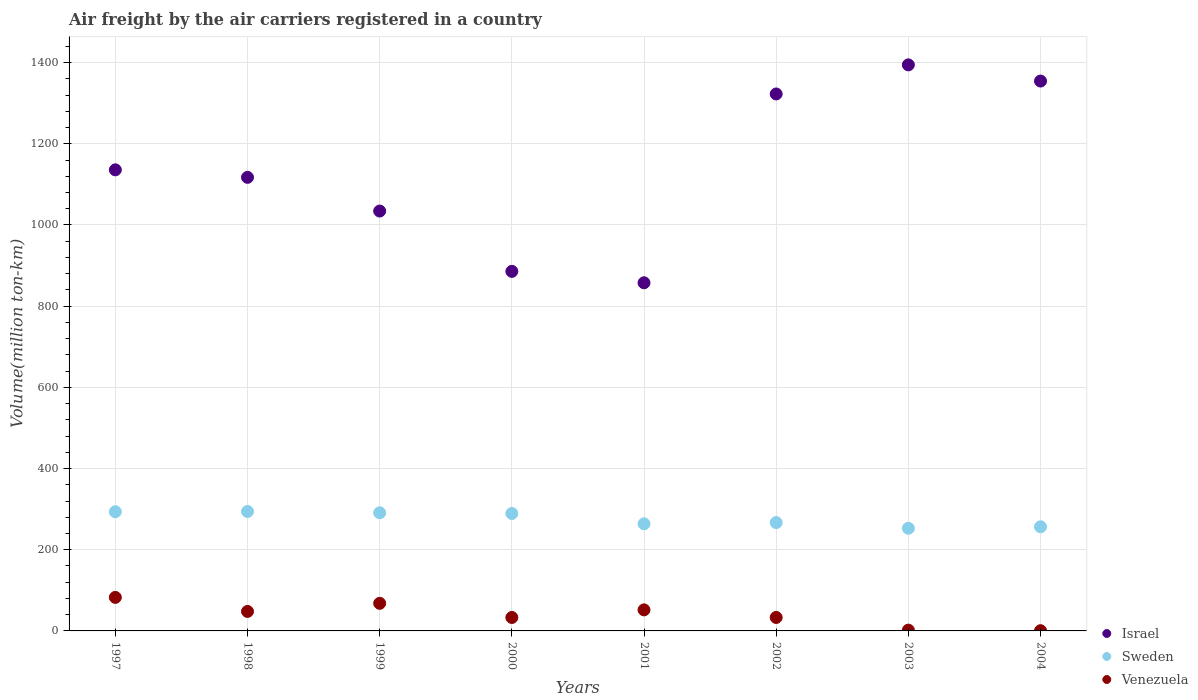How many different coloured dotlines are there?
Offer a terse response. 3. Is the number of dotlines equal to the number of legend labels?
Provide a short and direct response. Yes. What is the volume of the air carriers in Venezuela in 2002?
Provide a short and direct response. 33.17. Across all years, what is the maximum volume of the air carriers in Sweden?
Your response must be concise. 294.2. Across all years, what is the minimum volume of the air carriers in Sweden?
Make the answer very short. 252.88. What is the total volume of the air carriers in Israel in the graph?
Keep it short and to the point. 9102.32. What is the difference between the volume of the air carriers in Israel in 1997 and that in 1998?
Your answer should be very brief. 18.5. What is the difference between the volume of the air carriers in Sweden in 1999 and the volume of the air carriers in Venezuela in 2000?
Offer a very short reply. 257.9. What is the average volume of the air carriers in Israel per year?
Your response must be concise. 1137.79. In the year 2002, what is the difference between the volume of the air carriers in Sweden and volume of the air carriers in Israel?
Offer a terse response. -1055.88. In how many years, is the volume of the air carriers in Israel greater than 1040 million ton-km?
Your answer should be very brief. 5. What is the ratio of the volume of the air carriers in Venezuela in 2000 to that in 2001?
Keep it short and to the point. 0.64. Is the difference between the volume of the air carriers in Sweden in 2001 and 2002 greater than the difference between the volume of the air carriers in Israel in 2001 and 2002?
Keep it short and to the point. Yes. What is the difference between the highest and the second highest volume of the air carriers in Sweden?
Your answer should be compact. 0.6. What is the difference between the highest and the lowest volume of the air carriers in Sweden?
Give a very brief answer. 41.32. Is it the case that in every year, the sum of the volume of the air carriers in Venezuela and volume of the air carriers in Sweden  is greater than the volume of the air carriers in Israel?
Offer a very short reply. No. Does the volume of the air carriers in Israel monotonically increase over the years?
Your answer should be compact. No. Is the volume of the air carriers in Sweden strictly less than the volume of the air carriers in Venezuela over the years?
Give a very brief answer. No. How many dotlines are there?
Your answer should be compact. 3. How many years are there in the graph?
Ensure brevity in your answer.  8. What is the difference between two consecutive major ticks on the Y-axis?
Offer a very short reply. 200. Does the graph contain any zero values?
Your answer should be compact. No. Does the graph contain grids?
Give a very brief answer. Yes. Where does the legend appear in the graph?
Your answer should be compact. Bottom right. What is the title of the graph?
Ensure brevity in your answer.  Air freight by the air carriers registered in a country. Does "Malta" appear as one of the legend labels in the graph?
Offer a terse response. No. What is the label or title of the Y-axis?
Give a very brief answer. Volume(million ton-km). What is the Volume(million ton-km) of Israel in 1997?
Provide a succinct answer. 1135.8. What is the Volume(million ton-km) of Sweden in 1997?
Offer a terse response. 293.6. What is the Volume(million ton-km) in Venezuela in 1997?
Offer a very short reply. 82.6. What is the Volume(million ton-km) in Israel in 1998?
Your answer should be very brief. 1117.3. What is the Volume(million ton-km) of Sweden in 1998?
Make the answer very short. 294.2. What is the Volume(million ton-km) in Israel in 1999?
Give a very brief answer. 1034.3. What is the Volume(million ton-km) in Sweden in 1999?
Make the answer very short. 291. What is the Volume(million ton-km) of Venezuela in 1999?
Your response must be concise. 68. What is the Volume(million ton-km) in Israel in 2000?
Your answer should be compact. 885.7. What is the Volume(million ton-km) of Sweden in 2000?
Your answer should be very brief. 289.29. What is the Volume(million ton-km) in Venezuela in 2000?
Keep it short and to the point. 33.1. What is the Volume(million ton-km) of Israel in 2001?
Give a very brief answer. 857.56. What is the Volume(million ton-km) in Sweden in 2001?
Your response must be concise. 263.79. What is the Volume(million ton-km) of Venezuela in 2001?
Give a very brief answer. 51.86. What is the Volume(million ton-km) of Israel in 2002?
Provide a succinct answer. 1322.72. What is the Volume(million ton-km) of Sweden in 2002?
Offer a terse response. 266.84. What is the Volume(million ton-km) of Venezuela in 2002?
Provide a short and direct response. 33.17. What is the Volume(million ton-km) of Israel in 2003?
Ensure brevity in your answer.  1394.4. What is the Volume(million ton-km) in Sweden in 2003?
Give a very brief answer. 252.88. What is the Volume(million ton-km) of Venezuela in 2003?
Offer a terse response. 1.94. What is the Volume(million ton-km) in Israel in 2004?
Provide a short and direct response. 1354.54. What is the Volume(million ton-km) of Sweden in 2004?
Provide a short and direct response. 256.52. What is the Volume(million ton-km) of Venezuela in 2004?
Give a very brief answer. 0.56. Across all years, what is the maximum Volume(million ton-km) in Israel?
Your response must be concise. 1394.4. Across all years, what is the maximum Volume(million ton-km) in Sweden?
Your answer should be very brief. 294.2. Across all years, what is the maximum Volume(million ton-km) of Venezuela?
Provide a short and direct response. 82.6. Across all years, what is the minimum Volume(million ton-km) of Israel?
Provide a short and direct response. 857.56. Across all years, what is the minimum Volume(million ton-km) in Sweden?
Ensure brevity in your answer.  252.88. Across all years, what is the minimum Volume(million ton-km) in Venezuela?
Provide a short and direct response. 0.56. What is the total Volume(million ton-km) in Israel in the graph?
Your answer should be compact. 9102.32. What is the total Volume(million ton-km) of Sweden in the graph?
Make the answer very short. 2208.11. What is the total Volume(million ton-km) of Venezuela in the graph?
Provide a succinct answer. 319.23. What is the difference between the Volume(million ton-km) of Israel in 1997 and that in 1998?
Keep it short and to the point. 18.5. What is the difference between the Volume(million ton-km) of Venezuela in 1997 and that in 1998?
Your response must be concise. 34.6. What is the difference between the Volume(million ton-km) of Israel in 1997 and that in 1999?
Keep it short and to the point. 101.5. What is the difference between the Volume(million ton-km) of Sweden in 1997 and that in 1999?
Ensure brevity in your answer.  2.6. What is the difference between the Volume(million ton-km) in Venezuela in 1997 and that in 1999?
Provide a short and direct response. 14.6. What is the difference between the Volume(million ton-km) of Israel in 1997 and that in 2000?
Make the answer very short. 250.1. What is the difference between the Volume(million ton-km) of Sweden in 1997 and that in 2000?
Your response must be concise. 4.32. What is the difference between the Volume(million ton-km) of Venezuela in 1997 and that in 2000?
Keep it short and to the point. 49.5. What is the difference between the Volume(million ton-km) of Israel in 1997 and that in 2001?
Your answer should be very brief. 278.24. What is the difference between the Volume(million ton-km) in Sweden in 1997 and that in 2001?
Give a very brief answer. 29.81. What is the difference between the Volume(million ton-km) of Venezuela in 1997 and that in 2001?
Your answer should be compact. 30.74. What is the difference between the Volume(million ton-km) in Israel in 1997 and that in 2002?
Your response must be concise. -186.92. What is the difference between the Volume(million ton-km) in Sweden in 1997 and that in 2002?
Make the answer very short. 26.76. What is the difference between the Volume(million ton-km) of Venezuela in 1997 and that in 2002?
Provide a succinct answer. 49.43. What is the difference between the Volume(million ton-km) in Israel in 1997 and that in 2003?
Keep it short and to the point. -258.6. What is the difference between the Volume(million ton-km) in Sweden in 1997 and that in 2003?
Provide a short and direct response. 40.72. What is the difference between the Volume(million ton-km) of Venezuela in 1997 and that in 2003?
Offer a terse response. 80.66. What is the difference between the Volume(million ton-km) of Israel in 1997 and that in 2004?
Keep it short and to the point. -218.74. What is the difference between the Volume(million ton-km) in Sweden in 1997 and that in 2004?
Offer a terse response. 37.08. What is the difference between the Volume(million ton-km) of Venezuela in 1997 and that in 2004?
Your response must be concise. 82.04. What is the difference between the Volume(million ton-km) in Israel in 1998 and that in 1999?
Offer a very short reply. 83. What is the difference between the Volume(million ton-km) in Sweden in 1998 and that in 1999?
Make the answer very short. 3.2. What is the difference between the Volume(million ton-km) of Venezuela in 1998 and that in 1999?
Your answer should be very brief. -20. What is the difference between the Volume(million ton-km) of Israel in 1998 and that in 2000?
Your response must be concise. 231.6. What is the difference between the Volume(million ton-km) in Sweden in 1998 and that in 2000?
Keep it short and to the point. 4.92. What is the difference between the Volume(million ton-km) in Israel in 1998 and that in 2001?
Offer a terse response. 259.74. What is the difference between the Volume(million ton-km) in Sweden in 1998 and that in 2001?
Make the answer very short. 30.41. What is the difference between the Volume(million ton-km) of Venezuela in 1998 and that in 2001?
Your answer should be compact. -3.86. What is the difference between the Volume(million ton-km) of Israel in 1998 and that in 2002?
Provide a short and direct response. -205.42. What is the difference between the Volume(million ton-km) of Sweden in 1998 and that in 2002?
Keep it short and to the point. 27.36. What is the difference between the Volume(million ton-km) of Venezuela in 1998 and that in 2002?
Give a very brief answer. 14.83. What is the difference between the Volume(million ton-km) of Israel in 1998 and that in 2003?
Your response must be concise. -277.1. What is the difference between the Volume(million ton-km) in Sweden in 1998 and that in 2003?
Your answer should be compact. 41.32. What is the difference between the Volume(million ton-km) in Venezuela in 1998 and that in 2003?
Keep it short and to the point. 46.06. What is the difference between the Volume(million ton-km) in Israel in 1998 and that in 2004?
Give a very brief answer. -237.24. What is the difference between the Volume(million ton-km) of Sweden in 1998 and that in 2004?
Provide a short and direct response. 37.68. What is the difference between the Volume(million ton-km) in Venezuela in 1998 and that in 2004?
Offer a very short reply. 47.44. What is the difference between the Volume(million ton-km) in Israel in 1999 and that in 2000?
Offer a very short reply. 148.6. What is the difference between the Volume(million ton-km) in Sweden in 1999 and that in 2000?
Offer a very short reply. 1.72. What is the difference between the Volume(million ton-km) of Venezuela in 1999 and that in 2000?
Keep it short and to the point. 34.9. What is the difference between the Volume(million ton-km) in Israel in 1999 and that in 2001?
Your response must be concise. 176.74. What is the difference between the Volume(million ton-km) of Sweden in 1999 and that in 2001?
Ensure brevity in your answer.  27.21. What is the difference between the Volume(million ton-km) of Venezuela in 1999 and that in 2001?
Ensure brevity in your answer.  16.14. What is the difference between the Volume(million ton-km) of Israel in 1999 and that in 2002?
Provide a short and direct response. -288.42. What is the difference between the Volume(million ton-km) in Sweden in 1999 and that in 2002?
Your response must be concise. 24.16. What is the difference between the Volume(million ton-km) in Venezuela in 1999 and that in 2002?
Provide a succinct answer. 34.83. What is the difference between the Volume(million ton-km) of Israel in 1999 and that in 2003?
Make the answer very short. -360.1. What is the difference between the Volume(million ton-km) of Sweden in 1999 and that in 2003?
Your answer should be very brief. 38.12. What is the difference between the Volume(million ton-km) in Venezuela in 1999 and that in 2003?
Give a very brief answer. 66.06. What is the difference between the Volume(million ton-km) of Israel in 1999 and that in 2004?
Your response must be concise. -320.24. What is the difference between the Volume(million ton-km) of Sweden in 1999 and that in 2004?
Make the answer very short. 34.48. What is the difference between the Volume(million ton-km) in Venezuela in 1999 and that in 2004?
Offer a terse response. 67.44. What is the difference between the Volume(million ton-km) in Israel in 2000 and that in 2001?
Ensure brevity in your answer.  28.14. What is the difference between the Volume(million ton-km) in Sweden in 2000 and that in 2001?
Your answer should be compact. 25.5. What is the difference between the Volume(million ton-km) in Venezuela in 2000 and that in 2001?
Keep it short and to the point. -18.76. What is the difference between the Volume(million ton-km) of Israel in 2000 and that in 2002?
Your answer should be compact. -437.01. What is the difference between the Volume(million ton-km) of Sweden in 2000 and that in 2002?
Your answer should be very brief. 22.45. What is the difference between the Volume(million ton-km) in Venezuela in 2000 and that in 2002?
Provide a short and direct response. -0.07. What is the difference between the Volume(million ton-km) in Israel in 2000 and that in 2003?
Provide a succinct answer. -508.69. What is the difference between the Volume(million ton-km) of Sweden in 2000 and that in 2003?
Offer a terse response. 36.41. What is the difference between the Volume(million ton-km) in Venezuela in 2000 and that in 2003?
Provide a succinct answer. 31.16. What is the difference between the Volume(million ton-km) in Israel in 2000 and that in 2004?
Your answer should be very brief. -468.83. What is the difference between the Volume(million ton-km) of Sweden in 2000 and that in 2004?
Offer a terse response. 32.77. What is the difference between the Volume(million ton-km) in Venezuela in 2000 and that in 2004?
Make the answer very short. 32.54. What is the difference between the Volume(million ton-km) in Israel in 2001 and that in 2002?
Provide a short and direct response. -465.16. What is the difference between the Volume(million ton-km) of Sweden in 2001 and that in 2002?
Give a very brief answer. -3.05. What is the difference between the Volume(million ton-km) of Venezuela in 2001 and that in 2002?
Give a very brief answer. 18.69. What is the difference between the Volume(million ton-km) in Israel in 2001 and that in 2003?
Provide a succinct answer. -536.84. What is the difference between the Volume(million ton-km) of Sweden in 2001 and that in 2003?
Give a very brief answer. 10.91. What is the difference between the Volume(million ton-km) in Venezuela in 2001 and that in 2003?
Your answer should be very brief. 49.92. What is the difference between the Volume(million ton-km) in Israel in 2001 and that in 2004?
Ensure brevity in your answer.  -496.98. What is the difference between the Volume(million ton-km) in Sweden in 2001 and that in 2004?
Give a very brief answer. 7.27. What is the difference between the Volume(million ton-km) in Venezuela in 2001 and that in 2004?
Your response must be concise. 51.3. What is the difference between the Volume(million ton-km) of Israel in 2002 and that in 2003?
Keep it short and to the point. -71.68. What is the difference between the Volume(million ton-km) of Sweden in 2002 and that in 2003?
Offer a very short reply. 13.96. What is the difference between the Volume(million ton-km) in Venezuela in 2002 and that in 2003?
Provide a succinct answer. 31.23. What is the difference between the Volume(million ton-km) in Israel in 2002 and that in 2004?
Offer a very short reply. -31.82. What is the difference between the Volume(million ton-km) in Sweden in 2002 and that in 2004?
Provide a succinct answer. 10.32. What is the difference between the Volume(million ton-km) in Venezuela in 2002 and that in 2004?
Provide a short and direct response. 32.61. What is the difference between the Volume(million ton-km) of Israel in 2003 and that in 2004?
Provide a short and direct response. 39.86. What is the difference between the Volume(million ton-km) in Sweden in 2003 and that in 2004?
Your answer should be very brief. -3.64. What is the difference between the Volume(million ton-km) of Venezuela in 2003 and that in 2004?
Make the answer very short. 1.38. What is the difference between the Volume(million ton-km) of Israel in 1997 and the Volume(million ton-km) of Sweden in 1998?
Give a very brief answer. 841.6. What is the difference between the Volume(million ton-km) in Israel in 1997 and the Volume(million ton-km) in Venezuela in 1998?
Ensure brevity in your answer.  1087.8. What is the difference between the Volume(million ton-km) in Sweden in 1997 and the Volume(million ton-km) in Venezuela in 1998?
Provide a short and direct response. 245.6. What is the difference between the Volume(million ton-km) of Israel in 1997 and the Volume(million ton-km) of Sweden in 1999?
Give a very brief answer. 844.8. What is the difference between the Volume(million ton-km) in Israel in 1997 and the Volume(million ton-km) in Venezuela in 1999?
Offer a terse response. 1067.8. What is the difference between the Volume(million ton-km) in Sweden in 1997 and the Volume(million ton-km) in Venezuela in 1999?
Keep it short and to the point. 225.6. What is the difference between the Volume(million ton-km) in Israel in 1997 and the Volume(million ton-km) in Sweden in 2000?
Your response must be concise. 846.51. What is the difference between the Volume(million ton-km) of Israel in 1997 and the Volume(million ton-km) of Venezuela in 2000?
Provide a succinct answer. 1102.7. What is the difference between the Volume(million ton-km) of Sweden in 1997 and the Volume(million ton-km) of Venezuela in 2000?
Make the answer very short. 260.5. What is the difference between the Volume(million ton-km) in Israel in 1997 and the Volume(million ton-km) in Sweden in 2001?
Your response must be concise. 872.01. What is the difference between the Volume(million ton-km) of Israel in 1997 and the Volume(million ton-km) of Venezuela in 2001?
Keep it short and to the point. 1083.94. What is the difference between the Volume(million ton-km) of Sweden in 1997 and the Volume(million ton-km) of Venezuela in 2001?
Offer a very short reply. 241.74. What is the difference between the Volume(million ton-km) of Israel in 1997 and the Volume(million ton-km) of Sweden in 2002?
Offer a terse response. 868.96. What is the difference between the Volume(million ton-km) of Israel in 1997 and the Volume(million ton-km) of Venezuela in 2002?
Provide a short and direct response. 1102.63. What is the difference between the Volume(million ton-km) of Sweden in 1997 and the Volume(million ton-km) of Venezuela in 2002?
Offer a very short reply. 260.43. What is the difference between the Volume(million ton-km) of Israel in 1997 and the Volume(million ton-km) of Sweden in 2003?
Provide a succinct answer. 882.92. What is the difference between the Volume(million ton-km) in Israel in 1997 and the Volume(million ton-km) in Venezuela in 2003?
Offer a terse response. 1133.86. What is the difference between the Volume(million ton-km) of Sweden in 1997 and the Volume(million ton-km) of Venezuela in 2003?
Provide a short and direct response. 291.66. What is the difference between the Volume(million ton-km) in Israel in 1997 and the Volume(million ton-km) in Sweden in 2004?
Provide a short and direct response. 879.28. What is the difference between the Volume(million ton-km) of Israel in 1997 and the Volume(million ton-km) of Venezuela in 2004?
Give a very brief answer. 1135.24. What is the difference between the Volume(million ton-km) in Sweden in 1997 and the Volume(million ton-km) in Venezuela in 2004?
Provide a succinct answer. 293.04. What is the difference between the Volume(million ton-km) of Israel in 1998 and the Volume(million ton-km) of Sweden in 1999?
Keep it short and to the point. 826.3. What is the difference between the Volume(million ton-km) in Israel in 1998 and the Volume(million ton-km) in Venezuela in 1999?
Make the answer very short. 1049.3. What is the difference between the Volume(million ton-km) of Sweden in 1998 and the Volume(million ton-km) of Venezuela in 1999?
Give a very brief answer. 226.2. What is the difference between the Volume(million ton-km) in Israel in 1998 and the Volume(million ton-km) in Sweden in 2000?
Provide a succinct answer. 828.01. What is the difference between the Volume(million ton-km) in Israel in 1998 and the Volume(million ton-km) in Venezuela in 2000?
Your response must be concise. 1084.2. What is the difference between the Volume(million ton-km) of Sweden in 1998 and the Volume(million ton-km) of Venezuela in 2000?
Offer a very short reply. 261.1. What is the difference between the Volume(million ton-km) in Israel in 1998 and the Volume(million ton-km) in Sweden in 2001?
Offer a very short reply. 853.51. What is the difference between the Volume(million ton-km) in Israel in 1998 and the Volume(million ton-km) in Venezuela in 2001?
Offer a very short reply. 1065.44. What is the difference between the Volume(million ton-km) of Sweden in 1998 and the Volume(million ton-km) of Venezuela in 2001?
Your answer should be very brief. 242.34. What is the difference between the Volume(million ton-km) of Israel in 1998 and the Volume(million ton-km) of Sweden in 2002?
Your answer should be compact. 850.46. What is the difference between the Volume(million ton-km) of Israel in 1998 and the Volume(million ton-km) of Venezuela in 2002?
Offer a terse response. 1084.13. What is the difference between the Volume(million ton-km) in Sweden in 1998 and the Volume(million ton-km) in Venezuela in 2002?
Provide a short and direct response. 261.03. What is the difference between the Volume(million ton-km) in Israel in 1998 and the Volume(million ton-km) in Sweden in 2003?
Make the answer very short. 864.42. What is the difference between the Volume(million ton-km) in Israel in 1998 and the Volume(million ton-km) in Venezuela in 2003?
Offer a very short reply. 1115.36. What is the difference between the Volume(million ton-km) of Sweden in 1998 and the Volume(million ton-km) of Venezuela in 2003?
Give a very brief answer. 292.26. What is the difference between the Volume(million ton-km) in Israel in 1998 and the Volume(million ton-km) in Sweden in 2004?
Provide a short and direct response. 860.78. What is the difference between the Volume(million ton-km) in Israel in 1998 and the Volume(million ton-km) in Venezuela in 2004?
Keep it short and to the point. 1116.74. What is the difference between the Volume(million ton-km) in Sweden in 1998 and the Volume(million ton-km) in Venezuela in 2004?
Give a very brief answer. 293.64. What is the difference between the Volume(million ton-km) of Israel in 1999 and the Volume(million ton-km) of Sweden in 2000?
Offer a very short reply. 745.01. What is the difference between the Volume(million ton-km) in Israel in 1999 and the Volume(million ton-km) in Venezuela in 2000?
Provide a succinct answer. 1001.2. What is the difference between the Volume(million ton-km) of Sweden in 1999 and the Volume(million ton-km) of Venezuela in 2000?
Your answer should be very brief. 257.9. What is the difference between the Volume(million ton-km) of Israel in 1999 and the Volume(million ton-km) of Sweden in 2001?
Your answer should be compact. 770.51. What is the difference between the Volume(million ton-km) in Israel in 1999 and the Volume(million ton-km) in Venezuela in 2001?
Provide a short and direct response. 982.44. What is the difference between the Volume(million ton-km) of Sweden in 1999 and the Volume(million ton-km) of Venezuela in 2001?
Provide a short and direct response. 239.14. What is the difference between the Volume(million ton-km) of Israel in 1999 and the Volume(million ton-km) of Sweden in 2002?
Ensure brevity in your answer.  767.46. What is the difference between the Volume(million ton-km) in Israel in 1999 and the Volume(million ton-km) in Venezuela in 2002?
Your answer should be compact. 1001.13. What is the difference between the Volume(million ton-km) in Sweden in 1999 and the Volume(million ton-km) in Venezuela in 2002?
Ensure brevity in your answer.  257.83. What is the difference between the Volume(million ton-km) in Israel in 1999 and the Volume(million ton-km) in Sweden in 2003?
Offer a very short reply. 781.42. What is the difference between the Volume(million ton-km) of Israel in 1999 and the Volume(million ton-km) of Venezuela in 2003?
Provide a succinct answer. 1032.36. What is the difference between the Volume(million ton-km) in Sweden in 1999 and the Volume(million ton-km) in Venezuela in 2003?
Offer a very short reply. 289.06. What is the difference between the Volume(million ton-km) in Israel in 1999 and the Volume(million ton-km) in Sweden in 2004?
Provide a short and direct response. 777.78. What is the difference between the Volume(million ton-km) in Israel in 1999 and the Volume(million ton-km) in Venezuela in 2004?
Ensure brevity in your answer.  1033.74. What is the difference between the Volume(million ton-km) in Sweden in 1999 and the Volume(million ton-km) in Venezuela in 2004?
Offer a terse response. 290.44. What is the difference between the Volume(million ton-km) in Israel in 2000 and the Volume(million ton-km) in Sweden in 2001?
Offer a terse response. 621.92. What is the difference between the Volume(million ton-km) of Israel in 2000 and the Volume(million ton-km) of Venezuela in 2001?
Ensure brevity in your answer.  833.84. What is the difference between the Volume(million ton-km) in Sweden in 2000 and the Volume(million ton-km) in Venezuela in 2001?
Your answer should be very brief. 237.43. What is the difference between the Volume(million ton-km) of Israel in 2000 and the Volume(million ton-km) of Sweden in 2002?
Offer a very short reply. 618.87. What is the difference between the Volume(million ton-km) in Israel in 2000 and the Volume(million ton-km) in Venezuela in 2002?
Keep it short and to the point. 852.53. What is the difference between the Volume(million ton-km) in Sweden in 2000 and the Volume(million ton-km) in Venezuela in 2002?
Your answer should be compact. 256.12. What is the difference between the Volume(million ton-km) in Israel in 2000 and the Volume(million ton-km) in Sweden in 2003?
Provide a short and direct response. 632.82. What is the difference between the Volume(million ton-km) of Israel in 2000 and the Volume(million ton-km) of Venezuela in 2003?
Provide a short and direct response. 883.77. What is the difference between the Volume(million ton-km) of Sweden in 2000 and the Volume(million ton-km) of Venezuela in 2003?
Your answer should be compact. 287.35. What is the difference between the Volume(million ton-km) of Israel in 2000 and the Volume(million ton-km) of Sweden in 2004?
Offer a terse response. 629.19. What is the difference between the Volume(million ton-km) of Israel in 2000 and the Volume(million ton-km) of Venezuela in 2004?
Give a very brief answer. 885.14. What is the difference between the Volume(million ton-km) of Sweden in 2000 and the Volume(million ton-km) of Venezuela in 2004?
Your answer should be compact. 288.73. What is the difference between the Volume(million ton-km) in Israel in 2001 and the Volume(million ton-km) in Sweden in 2002?
Make the answer very short. 590.72. What is the difference between the Volume(million ton-km) of Israel in 2001 and the Volume(million ton-km) of Venezuela in 2002?
Keep it short and to the point. 824.39. What is the difference between the Volume(million ton-km) in Sweden in 2001 and the Volume(million ton-km) in Venezuela in 2002?
Keep it short and to the point. 230.62. What is the difference between the Volume(million ton-km) of Israel in 2001 and the Volume(million ton-km) of Sweden in 2003?
Ensure brevity in your answer.  604.68. What is the difference between the Volume(million ton-km) of Israel in 2001 and the Volume(million ton-km) of Venezuela in 2003?
Offer a very short reply. 855.62. What is the difference between the Volume(million ton-km) of Sweden in 2001 and the Volume(million ton-km) of Venezuela in 2003?
Offer a very short reply. 261.85. What is the difference between the Volume(million ton-km) of Israel in 2001 and the Volume(million ton-km) of Sweden in 2004?
Offer a very short reply. 601.04. What is the difference between the Volume(million ton-km) in Israel in 2001 and the Volume(million ton-km) in Venezuela in 2004?
Give a very brief answer. 857. What is the difference between the Volume(million ton-km) of Sweden in 2001 and the Volume(million ton-km) of Venezuela in 2004?
Ensure brevity in your answer.  263.23. What is the difference between the Volume(million ton-km) in Israel in 2002 and the Volume(million ton-km) in Sweden in 2003?
Make the answer very short. 1069.84. What is the difference between the Volume(million ton-km) in Israel in 2002 and the Volume(million ton-km) in Venezuela in 2003?
Give a very brief answer. 1320.78. What is the difference between the Volume(million ton-km) in Sweden in 2002 and the Volume(million ton-km) in Venezuela in 2003?
Your answer should be compact. 264.9. What is the difference between the Volume(million ton-km) of Israel in 2002 and the Volume(million ton-km) of Sweden in 2004?
Offer a very short reply. 1066.2. What is the difference between the Volume(million ton-km) of Israel in 2002 and the Volume(million ton-km) of Venezuela in 2004?
Your answer should be very brief. 1322.16. What is the difference between the Volume(million ton-km) in Sweden in 2002 and the Volume(million ton-km) in Venezuela in 2004?
Ensure brevity in your answer.  266.28. What is the difference between the Volume(million ton-km) of Israel in 2003 and the Volume(million ton-km) of Sweden in 2004?
Provide a short and direct response. 1137.88. What is the difference between the Volume(million ton-km) of Israel in 2003 and the Volume(million ton-km) of Venezuela in 2004?
Provide a short and direct response. 1393.84. What is the difference between the Volume(million ton-km) in Sweden in 2003 and the Volume(million ton-km) in Venezuela in 2004?
Offer a very short reply. 252.32. What is the average Volume(million ton-km) of Israel per year?
Offer a terse response. 1137.79. What is the average Volume(million ton-km) in Sweden per year?
Offer a terse response. 276.01. What is the average Volume(million ton-km) of Venezuela per year?
Provide a succinct answer. 39.9. In the year 1997, what is the difference between the Volume(million ton-km) of Israel and Volume(million ton-km) of Sweden?
Your answer should be very brief. 842.2. In the year 1997, what is the difference between the Volume(million ton-km) in Israel and Volume(million ton-km) in Venezuela?
Offer a terse response. 1053.2. In the year 1997, what is the difference between the Volume(million ton-km) of Sweden and Volume(million ton-km) of Venezuela?
Make the answer very short. 211. In the year 1998, what is the difference between the Volume(million ton-km) in Israel and Volume(million ton-km) in Sweden?
Your response must be concise. 823.1. In the year 1998, what is the difference between the Volume(million ton-km) of Israel and Volume(million ton-km) of Venezuela?
Make the answer very short. 1069.3. In the year 1998, what is the difference between the Volume(million ton-km) in Sweden and Volume(million ton-km) in Venezuela?
Your answer should be very brief. 246.2. In the year 1999, what is the difference between the Volume(million ton-km) in Israel and Volume(million ton-km) in Sweden?
Your response must be concise. 743.3. In the year 1999, what is the difference between the Volume(million ton-km) of Israel and Volume(million ton-km) of Venezuela?
Keep it short and to the point. 966.3. In the year 1999, what is the difference between the Volume(million ton-km) in Sweden and Volume(million ton-km) in Venezuela?
Ensure brevity in your answer.  223. In the year 2000, what is the difference between the Volume(million ton-km) of Israel and Volume(million ton-km) of Sweden?
Give a very brief answer. 596.42. In the year 2000, what is the difference between the Volume(million ton-km) of Israel and Volume(million ton-km) of Venezuela?
Offer a terse response. 852.6. In the year 2000, what is the difference between the Volume(million ton-km) in Sweden and Volume(million ton-km) in Venezuela?
Ensure brevity in your answer.  256.19. In the year 2001, what is the difference between the Volume(million ton-km) in Israel and Volume(million ton-km) in Sweden?
Keep it short and to the point. 593.77. In the year 2001, what is the difference between the Volume(million ton-km) in Israel and Volume(million ton-km) in Venezuela?
Your answer should be compact. 805.7. In the year 2001, what is the difference between the Volume(million ton-km) of Sweden and Volume(million ton-km) of Venezuela?
Give a very brief answer. 211.93. In the year 2002, what is the difference between the Volume(million ton-km) of Israel and Volume(million ton-km) of Sweden?
Keep it short and to the point. 1055.88. In the year 2002, what is the difference between the Volume(million ton-km) of Israel and Volume(million ton-km) of Venezuela?
Ensure brevity in your answer.  1289.55. In the year 2002, what is the difference between the Volume(million ton-km) of Sweden and Volume(million ton-km) of Venezuela?
Offer a very short reply. 233.67. In the year 2003, what is the difference between the Volume(million ton-km) of Israel and Volume(million ton-km) of Sweden?
Give a very brief answer. 1141.52. In the year 2003, what is the difference between the Volume(million ton-km) in Israel and Volume(million ton-km) in Venezuela?
Ensure brevity in your answer.  1392.46. In the year 2003, what is the difference between the Volume(million ton-km) in Sweden and Volume(million ton-km) in Venezuela?
Give a very brief answer. 250.94. In the year 2004, what is the difference between the Volume(million ton-km) in Israel and Volume(million ton-km) in Sweden?
Your response must be concise. 1098.02. In the year 2004, what is the difference between the Volume(million ton-km) in Israel and Volume(million ton-km) in Venezuela?
Offer a very short reply. 1353.98. In the year 2004, what is the difference between the Volume(million ton-km) of Sweden and Volume(million ton-km) of Venezuela?
Provide a succinct answer. 255.96. What is the ratio of the Volume(million ton-km) in Israel in 1997 to that in 1998?
Your answer should be very brief. 1.02. What is the ratio of the Volume(million ton-km) of Venezuela in 1997 to that in 1998?
Keep it short and to the point. 1.72. What is the ratio of the Volume(million ton-km) of Israel in 1997 to that in 1999?
Your answer should be very brief. 1.1. What is the ratio of the Volume(million ton-km) in Sweden in 1997 to that in 1999?
Make the answer very short. 1.01. What is the ratio of the Volume(million ton-km) of Venezuela in 1997 to that in 1999?
Offer a terse response. 1.21. What is the ratio of the Volume(million ton-km) of Israel in 1997 to that in 2000?
Make the answer very short. 1.28. What is the ratio of the Volume(million ton-km) of Sweden in 1997 to that in 2000?
Offer a terse response. 1.01. What is the ratio of the Volume(million ton-km) in Venezuela in 1997 to that in 2000?
Provide a succinct answer. 2.5. What is the ratio of the Volume(million ton-km) of Israel in 1997 to that in 2001?
Your response must be concise. 1.32. What is the ratio of the Volume(million ton-km) of Sweden in 1997 to that in 2001?
Give a very brief answer. 1.11. What is the ratio of the Volume(million ton-km) in Venezuela in 1997 to that in 2001?
Give a very brief answer. 1.59. What is the ratio of the Volume(million ton-km) of Israel in 1997 to that in 2002?
Keep it short and to the point. 0.86. What is the ratio of the Volume(million ton-km) in Sweden in 1997 to that in 2002?
Provide a short and direct response. 1.1. What is the ratio of the Volume(million ton-km) of Venezuela in 1997 to that in 2002?
Your response must be concise. 2.49. What is the ratio of the Volume(million ton-km) of Israel in 1997 to that in 2003?
Provide a short and direct response. 0.81. What is the ratio of the Volume(million ton-km) in Sweden in 1997 to that in 2003?
Offer a terse response. 1.16. What is the ratio of the Volume(million ton-km) in Venezuela in 1997 to that in 2003?
Your response must be concise. 42.64. What is the ratio of the Volume(million ton-km) in Israel in 1997 to that in 2004?
Provide a short and direct response. 0.84. What is the ratio of the Volume(million ton-km) in Sweden in 1997 to that in 2004?
Your answer should be compact. 1.14. What is the ratio of the Volume(million ton-km) in Venezuela in 1997 to that in 2004?
Your answer should be compact. 147.5. What is the ratio of the Volume(million ton-km) of Israel in 1998 to that in 1999?
Your answer should be compact. 1.08. What is the ratio of the Volume(million ton-km) of Venezuela in 1998 to that in 1999?
Provide a short and direct response. 0.71. What is the ratio of the Volume(million ton-km) in Israel in 1998 to that in 2000?
Offer a terse response. 1.26. What is the ratio of the Volume(million ton-km) of Venezuela in 1998 to that in 2000?
Your response must be concise. 1.45. What is the ratio of the Volume(million ton-km) in Israel in 1998 to that in 2001?
Your answer should be very brief. 1.3. What is the ratio of the Volume(million ton-km) in Sweden in 1998 to that in 2001?
Offer a very short reply. 1.12. What is the ratio of the Volume(million ton-km) in Venezuela in 1998 to that in 2001?
Offer a very short reply. 0.93. What is the ratio of the Volume(million ton-km) in Israel in 1998 to that in 2002?
Provide a succinct answer. 0.84. What is the ratio of the Volume(million ton-km) of Sweden in 1998 to that in 2002?
Provide a succinct answer. 1.1. What is the ratio of the Volume(million ton-km) of Venezuela in 1998 to that in 2002?
Give a very brief answer. 1.45. What is the ratio of the Volume(million ton-km) of Israel in 1998 to that in 2003?
Make the answer very short. 0.8. What is the ratio of the Volume(million ton-km) in Sweden in 1998 to that in 2003?
Offer a very short reply. 1.16. What is the ratio of the Volume(million ton-km) in Venezuela in 1998 to that in 2003?
Your answer should be very brief. 24.78. What is the ratio of the Volume(million ton-km) in Israel in 1998 to that in 2004?
Provide a succinct answer. 0.82. What is the ratio of the Volume(million ton-km) in Sweden in 1998 to that in 2004?
Provide a short and direct response. 1.15. What is the ratio of the Volume(million ton-km) in Venezuela in 1998 to that in 2004?
Provide a succinct answer. 85.71. What is the ratio of the Volume(million ton-km) in Israel in 1999 to that in 2000?
Provide a short and direct response. 1.17. What is the ratio of the Volume(million ton-km) of Sweden in 1999 to that in 2000?
Keep it short and to the point. 1.01. What is the ratio of the Volume(million ton-km) in Venezuela in 1999 to that in 2000?
Your response must be concise. 2.05. What is the ratio of the Volume(million ton-km) of Israel in 1999 to that in 2001?
Give a very brief answer. 1.21. What is the ratio of the Volume(million ton-km) in Sweden in 1999 to that in 2001?
Offer a terse response. 1.1. What is the ratio of the Volume(million ton-km) of Venezuela in 1999 to that in 2001?
Provide a succinct answer. 1.31. What is the ratio of the Volume(million ton-km) of Israel in 1999 to that in 2002?
Your answer should be very brief. 0.78. What is the ratio of the Volume(million ton-km) of Sweden in 1999 to that in 2002?
Offer a terse response. 1.09. What is the ratio of the Volume(million ton-km) of Venezuela in 1999 to that in 2002?
Your answer should be compact. 2.05. What is the ratio of the Volume(million ton-km) of Israel in 1999 to that in 2003?
Give a very brief answer. 0.74. What is the ratio of the Volume(million ton-km) of Sweden in 1999 to that in 2003?
Provide a short and direct response. 1.15. What is the ratio of the Volume(million ton-km) of Venezuela in 1999 to that in 2003?
Your response must be concise. 35.11. What is the ratio of the Volume(million ton-km) of Israel in 1999 to that in 2004?
Offer a terse response. 0.76. What is the ratio of the Volume(million ton-km) in Sweden in 1999 to that in 2004?
Make the answer very short. 1.13. What is the ratio of the Volume(million ton-km) of Venezuela in 1999 to that in 2004?
Your response must be concise. 121.43. What is the ratio of the Volume(million ton-km) of Israel in 2000 to that in 2001?
Ensure brevity in your answer.  1.03. What is the ratio of the Volume(million ton-km) of Sweden in 2000 to that in 2001?
Your answer should be compact. 1.1. What is the ratio of the Volume(million ton-km) in Venezuela in 2000 to that in 2001?
Your answer should be compact. 0.64. What is the ratio of the Volume(million ton-km) in Israel in 2000 to that in 2002?
Provide a succinct answer. 0.67. What is the ratio of the Volume(million ton-km) in Sweden in 2000 to that in 2002?
Give a very brief answer. 1.08. What is the ratio of the Volume(million ton-km) of Venezuela in 2000 to that in 2002?
Offer a very short reply. 1. What is the ratio of the Volume(million ton-km) of Israel in 2000 to that in 2003?
Your answer should be compact. 0.64. What is the ratio of the Volume(million ton-km) of Sweden in 2000 to that in 2003?
Provide a short and direct response. 1.14. What is the ratio of the Volume(million ton-km) of Venezuela in 2000 to that in 2003?
Offer a very short reply. 17.09. What is the ratio of the Volume(million ton-km) in Israel in 2000 to that in 2004?
Your response must be concise. 0.65. What is the ratio of the Volume(million ton-km) of Sweden in 2000 to that in 2004?
Give a very brief answer. 1.13. What is the ratio of the Volume(million ton-km) of Venezuela in 2000 to that in 2004?
Give a very brief answer. 59.11. What is the ratio of the Volume(million ton-km) of Israel in 2001 to that in 2002?
Provide a short and direct response. 0.65. What is the ratio of the Volume(million ton-km) of Venezuela in 2001 to that in 2002?
Provide a short and direct response. 1.56. What is the ratio of the Volume(million ton-km) of Israel in 2001 to that in 2003?
Offer a terse response. 0.61. What is the ratio of the Volume(million ton-km) in Sweden in 2001 to that in 2003?
Give a very brief answer. 1.04. What is the ratio of the Volume(million ton-km) of Venezuela in 2001 to that in 2003?
Give a very brief answer. 26.77. What is the ratio of the Volume(million ton-km) in Israel in 2001 to that in 2004?
Keep it short and to the point. 0.63. What is the ratio of the Volume(million ton-km) of Sweden in 2001 to that in 2004?
Make the answer very short. 1.03. What is the ratio of the Volume(million ton-km) in Venezuela in 2001 to that in 2004?
Your response must be concise. 92.61. What is the ratio of the Volume(million ton-km) of Israel in 2002 to that in 2003?
Ensure brevity in your answer.  0.95. What is the ratio of the Volume(million ton-km) of Sweden in 2002 to that in 2003?
Offer a terse response. 1.06. What is the ratio of the Volume(million ton-km) of Venezuela in 2002 to that in 2003?
Your answer should be compact. 17.12. What is the ratio of the Volume(million ton-km) in Israel in 2002 to that in 2004?
Give a very brief answer. 0.98. What is the ratio of the Volume(million ton-km) of Sweden in 2002 to that in 2004?
Provide a short and direct response. 1.04. What is the ratio of the Volume(million ton-km) in Venezuela in 2002 to that in 2004?
Provide a short and direct response. 59.23. What is the ratio of the Volume(million ton-km) of Israel in 2003 to that in 2004?
Provide a short and direct response. 1.03. What is the ratio of the Volume(million ton-km) in Sweden in 2003 to that in 2004?
Your answer should be very brief. 0.99. What is the ratio of the Volume(million ton-km) in Venezuela in 2003 to that in 2004?
Provide a short and direct response. 3.46. What is the difference between the highest and the second highest Volume(million ton-km) in Israel?
Make the answer very short. 39.86. What is the difference between the highest and the second highest Volume(million ton-km) in Sweden?
Provide a succinct answer. 0.6. What is the difference between the highest and the second highest Volume(million ton-km) of Venezuela?
Offer a very short reply. 14.6. What is the difference between the highest and the lowest Volume(million ton-km) of Israel?
Offer a very short reply. 536.84. What is the difference between the highest and the lowest Volume(million ton-km) in Sweden?
Make the answer very short. 41.32. What is the difference between the highest and the lowest Volume(million ton-km) in Venezuela?
Offer a terse response. 82.04. 